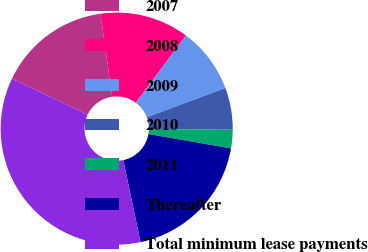<chart> <loc_0><loc_0><loc_500><loc_500><pie_chart><fcel>2007<fcel>2008<fcel>2009<fcel>2010<fcel>2011<fcel>Thereafter<fcel>Total minimum lease payments<nl><fcel>15.69%<fcel>12.41%<fcel>9.13%<fcel>5.85%<fcel>2.57%<fcel>18.97%<fcel>35.37%<nl></chart> 